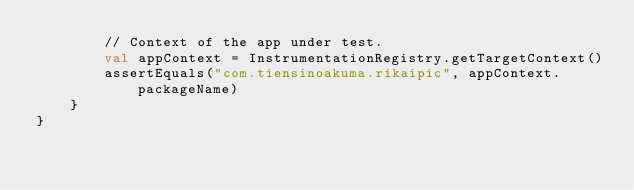Convert code to text. <code><loc_0><loc_0><loc_500><loc_500><_Kotlin_>        // Context of the app under test.
        val appContext = InstrumentationRegistry.getTargetContext()
        assertEquals("com.tiensinoakuma.rikaipic", appContext.packageName)
    }
}
</code> 